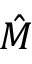Convert formula to latex. <formula><loc_0><loc_0><loc_500><loc_500>\hat { M }</formula> 